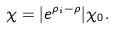<formula> <loc_0><loc_0><loc_500><loc_500>\chi = | e ^ { \rho _ { i } - \rho } | \chi _ { 0 } .</formula> 